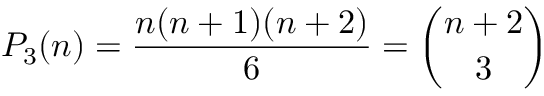<formula> <loc_0><loc_0><loc_500><loc_500>P _ { 3 } ( n ) = { \frac { n ( n + 1 ) ( n + 2 ) } { 6 } } = { \binom { n + 2 } { 3 } }</formula> 